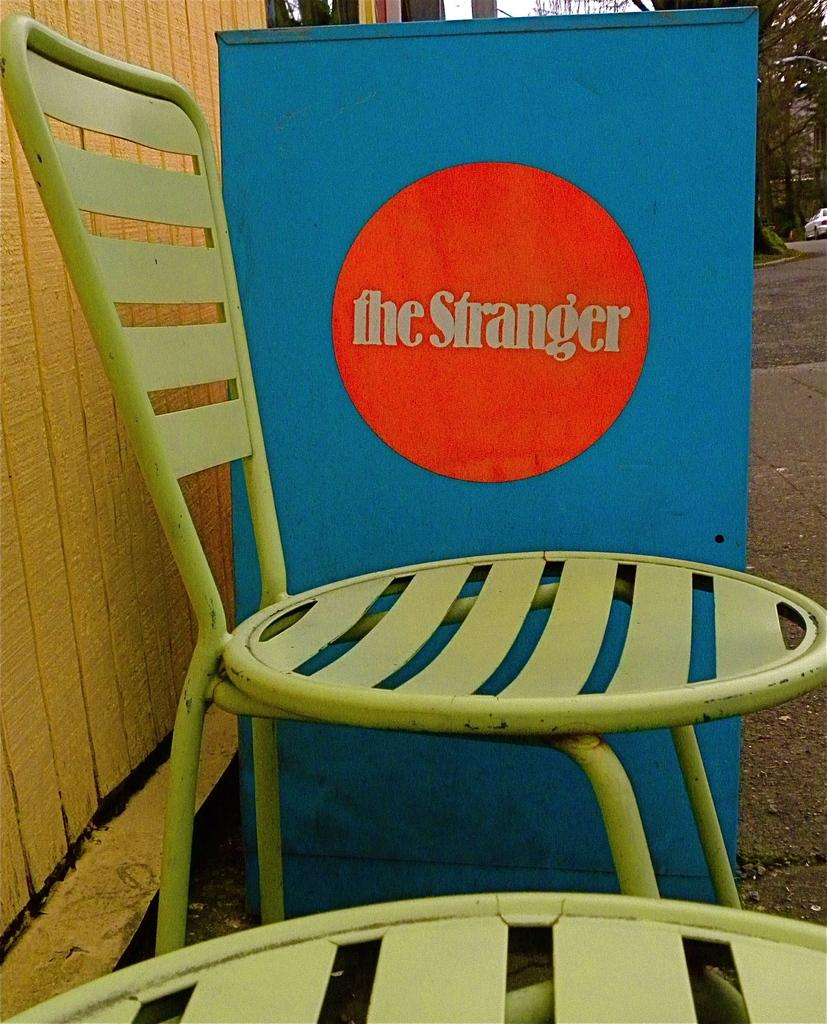What type of furniture can be seen in the image? There are chairs in the image. What is written or displayed on the board? There is text written on a board in the image. What material is the wooden object made of? The wooden object in the image is made of wood. What can be seen in the background of the image? There are trees, a vehicle, and a road in the background of the image. Can you tell me how many kettles are visible in the image? There are no kettles present in the image. What angle is the wooden object leaning at in the image? The wooden object is not leaning in the image; it is stationary. 